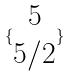Convert formula to latex. <formula><loc_0><loc_0><loc_500><loc_500>\{ \begin{matrix} 5 \\ 5 / 2 \end{matrix} \}</formula> 